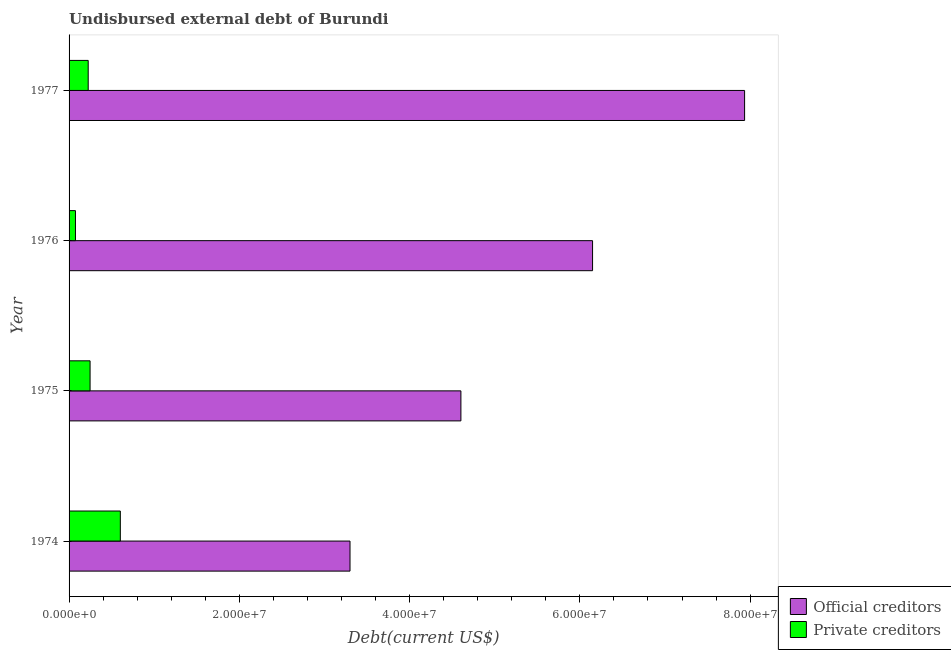How many different coloured bars are there?
Offer a very short reply. 2. Are the number of bars per tick equal to the number of legend labels?
Keep it short and to the point. Yes. Are the number of bars on each tick of the Y-axis equal?
Offer a terse response. Yes. How many bars are there on the 4th tick from the bottom?
Offer a terse response. 2. What is the label of the 2nd group of bars from the top?
Provide a succinct answer. 1976. What is the undisbursed external debt of official creditors in 1975?
Your answer should be very brief. 4.60e+07. Across all years, what is the maximum undisbursed external debt of private creditors?
Keep it short and to the point. 6.02e+06. Across all years, what is the minimum undisbursed external debt of private creditors?
Keep it short and to the point. 7.52e+05. In which year was the undisbursed external debt of official creditors minimum?
Provide a short and direct response. 1974. What is the total undisbursed external debt of official creditors in the graph?
Offer a terse response. 2.20e+08. What is the difference between the undisbursed external debt of private creditors in 1974 and that in 1976?
Make the answer very short. 5.27e+06. What is the difference between the undisbursed external debt of private creditors in 1975 and the undisbursed external debt of official creditors in 1974?
Provide a short and direct response. -3.05e+07. What is the average undisbursed external debt of official creditors per year?
Your answer should be compact. 5.50e+07. In the year 1974, what is the difference between the undisbursed external debt of official creditors and undisbursed external debt of private creditors?
Make the answer very short. 2.70e+07. In how many years, is the undisbursed external debt of private creditors greater than 16000000 US$?
Ensure brevity in your answer.  0. What is the ratio of the undisbursed external debt of official creditors in 1976 to that in 1977?
Provide a succinct answer. 0.78. Is the undisbursed external debt of private creditors in 1974 less than that in 1976?
Your response must be concise. No. What is the difference between the highest and the second highest undisbursed external debt of official creditors?
Your answer should be very brief. 1.79e+07. What is the difference between the highest and the lowest undisbursed external debt of official creditors?
Keep it short and to the point. 4.63e+07. What does the 2nd bar from the top in 1977 represents?
Keep it short and to the point. Official creditors. What does the 2nd bar from the bottom in 1977 represents?
Your answer should be very brief. Private creditors. How many bars are there?
Offer a very short reply. 8. Are all the bars in the graph horizontal?
Your answer should be compact. Yes. What is the difference between two consecutive major ticks on the X-axis?
Offer a terse response. 2.00e+07. Where does the legend appear in the graph?
Provide a succinct answer. Bottom right. How many legend labels are there?
Offer a very short reply. 2. How are the legend labels stacked?
Provide a succinct answer. Vertical. What is the title of the graph?
Give a very brief answer. Undisbursed external debt of Burundi. What is the label or title of the X-axis?
Your response must be concise. Debt(current US$). What is the Debt(current US$) in Official creditors in 1974?
Offer a terse response. 3.30e+07. What is the Debt(current US$) in Private creditors in 1974?
Provide a succinct answer. 6.02e+06. What is the Debt(current US$) of Official creditors in 1975?
Your answer should be very brief. 4.60e+07. What is the Debt(current US$) of Private creditors in 1975?
Provide a succinct answer. 2.47e+06. What is the Debt(current US$) in Official creditors in 1976?
Offer a very short reply. 6.15e+07. What is the Debt(current US$) in Private creditors in 1976?
Your answer should be compact. 7.52e+05. What is the Debt(current US$) in Official creditors in 1977?
Your response must be concise. 7.93e+07. What is the Debt(current US$) in Private creditors in 1977?
Ensure brevity in your answer.  2.25e+06. Across all years, what is the maximum Debt(current US$) in Official creditors?
Provide a short and direct response. 7.93e+07. Across all years, what is the maximum Debt(current US$) in Private creditors?
Ensure brevity in your answer.  6.02e+06. Across all years, what is the minimum Debt(current US$) in Official creditors?
Offer a very short reply. 3.30e+07. Across all years, what is the minimum Debt(current US$) of Private creditors?
Your answer should be compact. 7.52e+05. What is the total Debt(current US$) of Official creditors in the graph?
Give a very brief answer. 2.20e+08. What is the total Debt(current US$) in Private creditors in the graph?
Your answer should be very brief. 1.15e+07. What is the difference between the Debt(current US$) of Official creditors in 1974 and that in 1975?
Your answer should be compact. -1.30e+07. What is the difference between the Debt(current US$) of Private creditors in 1974 and that in 1975?
Keep it short and to the point. 3.55e+06. What is the difference between the Debt(current US$) of Official creditors in 1974 and that in 1976?
Provide a succinct answer. -2.85e+07. What is the difference between the Debt(current US$) in Private creditors in 1974 and that in 1976?
Your response must be concise. 5.27e+06. What is the difference between the Debt(current US$) in Official creditors in 1974 and that in 1977?
Make the answer very short. -4.63e+07. What is the difference between the Debt(current US$) in Private creditors in 1974 and that in 1977?
Your response must be concise. 3.77e+06. What is the difference between the Debt(current US$) in Official creditors in 1975 and that in 1976?
Offer a very short reply. -1.55e+07. What is the difference between the Debt(current US$) of Private creditors in 1975 and that in 1976?
Provide a short and direct response. 1.72e+06. What is the difference between the Debt(current US$) of Official creditors in 1975 and that in 1977?
Ensure brevity in your answer.  -3.33e+07. What is the difference between the Debt(current US$) in Private creditors in 1975 and that in 1977?
Offer a terse response. 2.20e+05. What is the difference between the Debt(current US$) in Official creditors in 1976 and that in 1977?
Your response must be concise. -1.79e+07. What is the difference between the Debt(current US$) in Private creditors in 1976 and that in 1977?
Your response must be concise. -1.50e+06. What is the difference between the Debt(current US$) of Official creditors in 1974 and the Debt(current US$) of Private creditors in 1975?
Offer a very short reply. 3.05e+07. What is the difference between the Debt(current US$) of Official creditors in 1974 and the Debt(current US$) of Private creditors in 1976?
Offer a very short reply. 3.22e+07. What is the difference between the Debt(current US$) in Official creditors in 1974 and the Debt(current US$) in Private creditors in 1977?
Your answer should be very brief. 3.08e+07. What is the difference between the Debt(current US$) of Official creditors in 1975 and the Debt(current US$) of Private creditors in 1976?
Provide a short and direct response. 4.53e+07. What is the difference between the Debt(current US$) in Official creditors in 1975 and the Debt(current US$) in Private creditors in 1977?
Give a very brief answer. 4.38e+07. What is the difference between the Debt(current US$) of Official creditors in 1976 and the Debt(current US$) of Private creditors in 1977?
Your answer should be very brief. 5.92e+07. What is the average Debt(current US$) in Official creditors per year?
Offer a terse response. 5.50e+07. What is the average Debt(current US$) in Private creditors per year?
Give a very brief answer. 2.87e+06. In the year 1974, what is the difference between the Debt(current US$) in Official creditors and Debt(current US$) in Private creditors?
Your response must be concise. 2.70e+07. In the year 1975, what is the difference between the Debt(current US$) of Official creditors and Debt(current US$) of Private creditors?
Your answer should be compact. 4.36e+07. In the year 1976, what is the difference between the Debt(current US$) in Official creditors and Debt(current US$) in Private creditors?
Your answer should be compact. 6.07e+07. In the year 1977, what is the difference between the Debt(current US$) in Official creditors and Debt(current US$) in Private creditors?
Keep it short and to the point. 7.71e+07. What is the ratio of the Debt(current US$) in Official creditors in 1974 to that in 1975?
Give a very brief answer. 0.72. What is the ratio of the Debt(current US$) of Private creditors in 1974 to that in 1975?
Ensure brevity in your answer.  2.44. What is the ratio of the Debt(current US$) of Official creditors in 1974 to that in 1976?
Give a very brief answer. 0.54. What is the ratio of the Debt(current US$) in Private creditors in 1974 to that in 1976?
Offer a terse response. 8.01. What is the ratio of the Debt(current US$) of Official creditors in 1974 to that in 1977?
Offer a very short reply. 0.42. What is the ratio of the Debt(current US$) of Private creditors in 1974 to that in 1977?
Your response must be concise. 2.68. What is the ratio of the Debt(current US$) in Official creditors in 1975 to that in 1976?
Give a very brief answer. 0.75. What is the ratio of the Debt(current US$) in Private creditors in 1975 to that in 1976?
Make the answer very short. 3.28. What is the ratio of the Debt(current US$) in Official creditors in 1975 to that in 1977?
Your answer should be compact. 0.58. What is the ratio of the Debt(current US$) in Private creditors in 1975 to that in 1977?
Offer a very short reply. 1.1. What is the ratio of the Debt(current US$) of Official creditors in 1976 to that in 1977?
Your answer should be compact. 0.78. What is the ratio of the Debt(current US$) of Private creditors in 1976 to that in 1977?
Give a very brief answer. 0.33. What is the difference between the highest and the second highest Debt(current US$) in Official creditors?
Offer a very short reply. 1.79e+07. What is the difference between the highest and the second highest Debt(current US$) of Private creditors?
Offer a very short reply. 3.55e+06. What is the difference between the highest and the lowest Debt(current US$) in Official creditors?
Your response must be concise. 4.63e+07. What is the difference between the highest and the lowest Debt(current US$) of Private creditors?
Your answer should be compact. 5.27e+06. 